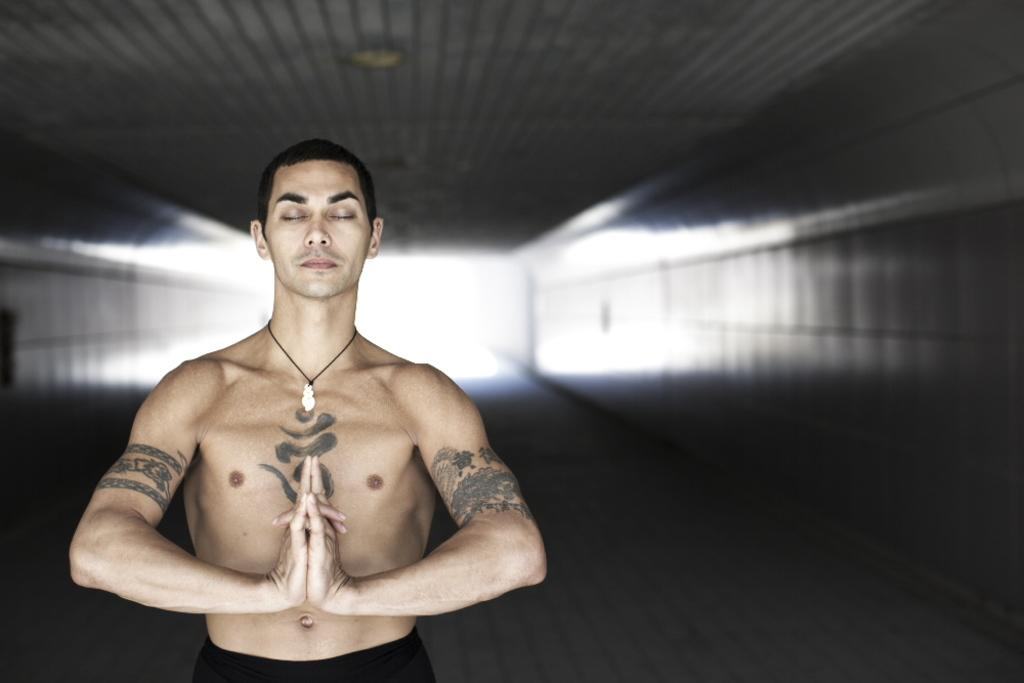Who is present in the image? There is a man standing in the image. What can be seen in the background of the image? There is a wall in the background of the image. What type of room is visible in the image? There is no room visible in the image; it only shows a man standing in front of a wall. Can you see an airport in the image? There is no airport present in the image. 